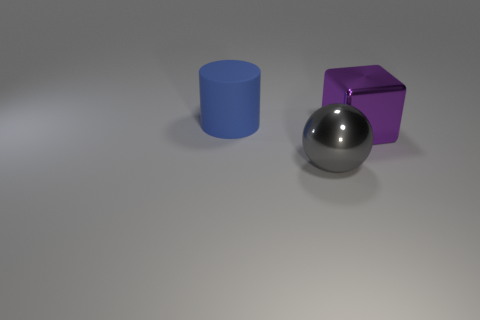How many metallic spheres are on the right side of the big purple metal cube?
Give a very brief answer. 0. What size is the blue object?
Make the answer very short. Large. The ball that is the same size as the matte object is what color?
Your answer should be very brief. Gray. What is the big ball made of?
Your answer should be compact. Metal. How many small gray metallic cylinders are there?
Provide a short and direct response. 0. There is a object left of the gray object; is it the same color as the thing on the right side of the large gray sphere?
Make the answer very short. No. What number of other objects are there of the same size as the blue rubber cylinder?
Make the answer very short. 2. The large shiny thing that is behind the gray ball is what color?
Offer a terse response. Purple. Is the material of the thing that is behind the metal cube the same as the purple cube?
Make the answer very short. No. How many things are both behind the large gray metal sphere and right of the blue rubber object?
Make the answer very short. 1. 